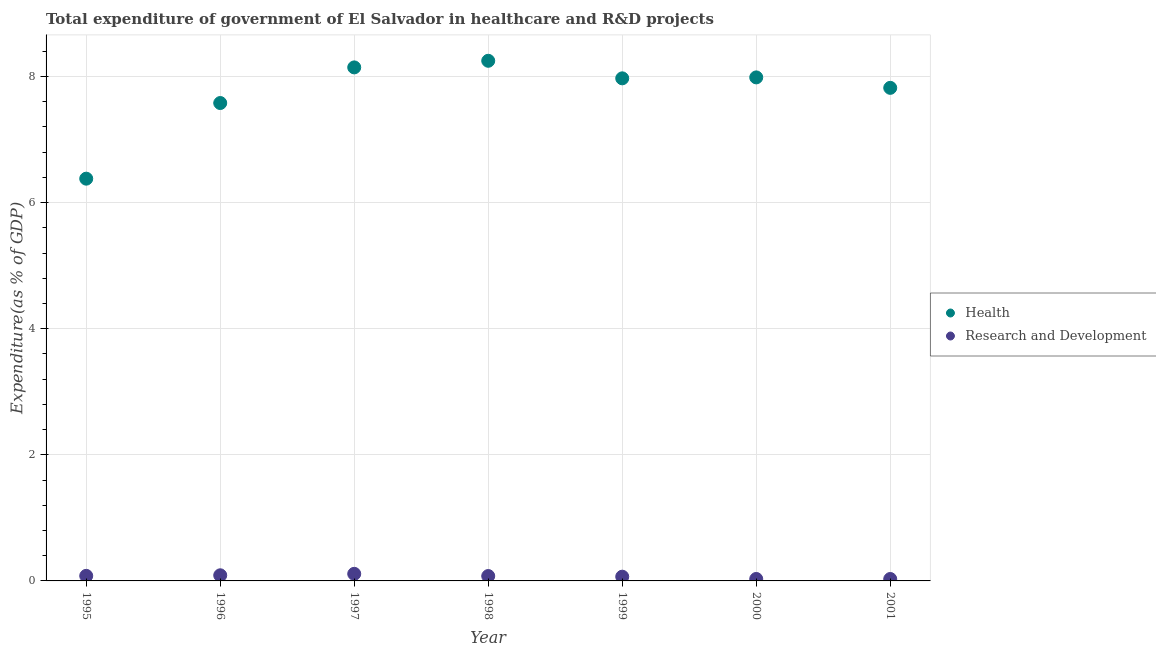Is the number of dotlines equal to the number of legend labels?
Give a very brief answer. Yes. What is the expenditure in r&d in 1997?
Your response must be concise. 0.11. Across all years, what is the maximum expenditure in healthcare?
Keep it short and to the point. 8.25. Across all years, what is the minimum expenditure in healthcare?
Provide a succinct answer. 6.38. In which year was the expenditure in healthcare maximum?
Keep it short and to the point. 1998. What is the total expenditure in healthcare in the graph?
Ensure brevity in your answer.  54.12. What is the difference between the expenditure in healthcare in 1997 and that in 1999?
Provide a short and direct response. 0.17. What is the difference between the expenditure in healthcare in 2001 and the expenditure in r&d in 1995?
Your answer should be very brief. 7.74. What is the average expenditure in healthcare per year?
Make the answer very short. 7.73. In the year 1997, what is the difference between the expenditure in r&d and expenditure in healthcare?
Your answer should be compact. -8.03. What is the ratio of the expenditure in r&d in 1996 to that in 1999?
Ensure brevity in your answer.  1.33. Is the expenditure in r&d in 1996 less than that in 1998?
Offer a very short reply. No. What is the difference between the highest and the second highest expenditure in healthcare?
Give a very brief answer. 0.1. What is the difference between the highest and the lowest expenditure in r&d?
Provide a short and direct response. 0.08. Is the sum of the expenditure in healthcare in 1995 and 2001 greater than the maximum expenditure in r&d across all years?
Your answer should be compact. Yes. Is the expenditure in r&d strictly greater than the expenditure in healthcare over the years?
Give a very brief answer. No. Is the expenditure in healthcare strictly less than the expenditure in r&d over the years?
Give a very brief answer. No. How many dotlines are there?
Offer a very short reply. 2. What is the difference between two consecutive major ticks on the Y-axis?
Give a very brief answer. 2. Are the values on the major ticks of Y-axis written in scientific E-notation?
Ensure brevity in your answer.  No. Does the graph contain grids?
Keep it short and to the point. Yes. Where does the legend appear in the graph?
Provide a succinct answer. Center right. What is the title of the graph?
Your response must be concise. Total expenditure of government of El Salvador in healthcare and R&D projects. What is the label or title of the Y-axis?
Provide a short and direct response. Expenditure(as % of GDP). What is the Expenditure(as % of GDP) of Health in 1995?
Offer a very short reply. 6.38. What is the Expenditure(as % of GDP) of Research and Development in 1995?
Offer a terse response. 0.08. What is the Expenditure(as % of GDP) of Health in 1996?
Offer a very short reply. 7.58. What is the Expenditure(as % of GDP) in Research and Development in 1996?
Offer a very short reply. 0.09. What is the Expenditure(as % of GDP) in Health in 1997?
Keep it short and to the point. 8.14. What is the Expenditure(as % of GDP) in Research and Development in 1997?
Your answer should be very brief. 0.11. What is the Expenditure(as % of GDP) of Health in 1998?
Keep it short and to the point. 8.25. What is the Expenditure(as % of GDP) of Research and Development in 1998?
Provide a short and direct response. 0.08. What is the Expenditure(as % of GDP) of Health in 1999?
Your answer should be very brief. 7.97. What is the Expenditure(as % of GDP) of Research and Development in 1999?
Ensure brevity in your answer.  0.07. What is the Expenditure(as % of GDP) in Health in 2000?
Offer a terse response. 7.98. What is the Expenditure(as % of GDP) in Research and Development in 2000?
Make the answer very short. 0.03. What is the Expenditure(as % of GDP) in Health in 2001?
Your response must be concise. 7.82. What is the Expenditure(as % of GDP) in Research and Development in 2001?
Keep it short and to the point. 0.03. Across all years, what is the maximum Expenditure(as % of GDP) of Health?
Give a very brief answer. 8.25. Across all years, what is the maximum Expenditure(as % of GDP) of Research and Development?
Offer a very short reply. 0.11. Across all years, what is the minimum Expenditure(as % of GDP) of Health?
Provide a succinct answer. 6.38. Across all years, what is the minimum Expenditure(as % of GDP) of Research and Development?
Make the answer very short. 0.03. What is the total Expenditure(as % of GDP) in Health in the graph?
Keep it short and to the point. 54.12. What is the total Expenditure(as % of GDP) in Research and Development in the graph?
Provide a succinct answer. 0.49. What is the difference between the Expenditure(as % of GDP) of Health in 1995 and that in 1996?
Offer a terse response. -1.2. What is the difference between the Expenditure(as % of GDP) in Research and Development in 1995 and that in 1996?
Ensure brevity in your answer.  -0.01. What is the difference between the Expenditure(as % of GDP) of Health in 1995 and that in 1997?
Offer a very short reply. -1.76. What is the difference between the Expenditure(as % of GDP) of Research and Development in 1995 and that in 1997?
Your answer should be very brief. -0.03. What is the difference between the Expenditure(as % of GDP) of Health in 1995 and that in 1998?
Ensure brevity in your answer.  -1.87. What is the difference between the Expenditure(as % of GDP) of Research and Development in 1995 and that in 1998?
Make the answer very short. 0. What is the difference between the Expenditure(as % of GDP) of Health in 1995 and that in 1999?
Provide a short and direct response. -1.59. What is the difference between the Expenditure(as % of GDP) of Research and Development in 1995 and that in 1999?
Your answer should be compact. 0.01. What is the difference between the Expenditure(as % of GDP) of Health in 1995 and that in 2000?
Ensure brevity in your answer.  -1.61. What is the difference between the Expenditure(as % of GDP) of Research and Development in 1995 and that in 2000?
Make the answer very short. 0.05. What is the difference between the Expenditure(as % of GDP) in Health in 1995 and that in 2001?
Make the answer very short. -1.44. What is the difference between the Expenditure(as % of GDP) of Research and Development in 1995 and that in 2001?
Offer a very short reply. 0.05. What is the difference between the Expenditure(as % of GDP) in Health in 1996 and that in 1997?
Make the answer very short. -0.56. What is the difference between the Expenditure(as % of GDP) of Research and Development in 1996 and that in 1997?
Ensure brevity in your answer.  -0.02. What is the difference between the Expenditure(as % of GDP) of Health in 1996 and that in 1998?
Offer a very short reply. -0.67. What is the difference between the Expenditure(as % of GDP) in Research and Development in 1996 and that in 1998?
Provide a short and direct response. 0.01. What is the difference between the Expenditure(as % of GDP) in Health in 1996 and that in 1999?
Ensure brevity in your answer.  -0.39. What is the difference between the Expenditure(as % of GDP) in Research and Development in 1996 and that in 1999?
Offer a very short reply. 0.02. What is the difference between the Expenditure(as % of GDP) in Health in 1996 and that in 2000?
Ensure brevity in your answer.  -0.41. What is the difference between the Expenditure(as % of GDP) of Research and Development in 1996 and that in 2000?
Offer a terse response. 0.06. What is the difference between the Expenditure(as % of GDP) in Health in 1996 and that in 2001?
Keep it short and to the point. -0.24. What is the difference between the Expenditure(as % of GDP) in Research and Development in 1996 and that in 2001?
Ensure brevity in your answer.  0.06. What is the difference between the Expenditure(as % of GDP) in Health in 1997 and that in 1998?
Offer a very short reply. -0.1. What is the difference between the Expenditure(as % of GDP) of Research and Development in 1997 and that in 1998?
Keep it short and to the point. 0.04. What is the difference between the Expenditure(as % of GDP) in Health in 1997 and that in 1999?
Your response must be concise. 0.17. What is the difference between the Expenditure(as % of GDP) of Research and Development in 1997 and that in 1999?
Your answer should be compact. 0.05. What is the difference between the Expenditure(as % of GDP) in Health in 1997 and that in 2000?
Give a very brief answer. 0.16. What is the difference between the Expenditure(as % of GDP) of Research and Development in 1997 and that in 2000?
Your answer should be very brief. 0.08. What is the difference between the Expenditure(as % of GDP) of Health in 1997 and that in 2001?
Offer a terse response. 0.32. What is the difference between the Expenditure(as % of GDP) in Research and Development in 1997 and that in 2001?
Your response must be concise. 0.08. What is the difference between the Expenditure(as % of GDP) in Health in 1998 and that in 1999?
Provide a succinct answer. 0.28. What is the difference between the Expenditure(as % of GDP) in Research and Development in 1998 and that in 1999?
Your answer should be compact. 0.01. What is the difference between the Expenditure(as % of GDP) in Health in 1998 and that in 2000?
Your response must be concise. 0.26. What is the difference between the Expenditure(as % of GDP) in Research and Development in 1998 and that in 2000?
Offer a terse response. 0.05. What is the difference between the Expenditure(as % of GDP) of Health in 1998 and that in 2001?
Offer a very short reply. 0.43. What is the difference between the Expenditure(as % of GDP) in Research and Development in 1998 and that in 2001?
Provide a succinct answer. 0.05. What is the difference between the Expenditure(as % of GDP) of Health in 1999 and that in 2000?
Give a very brief answer. -0.01. What is the difference between the Expenditure(as % of GDP) in Research and Development in 1999 and that in 2000?
Provide a succinct answer. 0.04. What is the difference between the Expenditure(as % of GDP) of Health in 1999 and that in 2001?
Your answer should be compact. 0.15. What is the difference between the Expenditure(as % of GDP) in Research and Development in 1999 and that in 2001?
Ensure brevity in your answer.  0.04. What is the difference between the Expenditure(as % of GDP) of Health in 2000 and that in 2001?
Your response must be concise. 0.17. What is the difference between the Expenditure(as % of GDP) of Research and Development in 2000 and that in 2001?
Make the answer very short. 0. What is the difference between the Expenditure(as % of GDP) of Health in 1995 and the Expenditure(as % of GDP) of Research and Development in 1996?
Your response must be concise. 6.29. What is the difference between the Expenditure(as % of GDP) in Health in 1995 and the Expenditure(as % of GDP) in Research and Development in 1997?
Your answer should be compact. 6.27. What is the difference between the Expenditure(as % of GDP) of Health in 1995 and the Expenditure(as % of GDP) of Research and Development in 1998?
Your answer should be very brief. 6.3. What is the difference between the Expenditure(as % of GDP) of Health in 1995 and the Expenditure(as % of GDP) of Research and Development in 1999?
Ensure brevity in your answer.  6.31. What is the difference between the Expenditure(as % of GDP) in Health in 1995 and the Expenditure(as % of GDP) in Research and Development in 2000?
Make the answer very short. 6.35. What is the difference between the Expenditure(as % of GDP) in Health in 1995 and the Expenditure(as % of GDP) in Research and Development in 2001?
Provide a succinct answer. 6.35. What is the difference between the Expenditure(as % of GDP) in Health in 1996 and the Expenditure(as % of GDP) in Research and Development in 1997?
Ensure brevity in your answer.  7.47. What is the difference between the Expenditure(as % of GDP) of Health in 1996 and the Expenditure(as % of GDP) of Research and Development in 1998?
Your answer should be very brief. 7.5. What is the difference between the Expenditure(as % of GDP) of Health in 1996 and the Expenditure(as % of GDP) of Research and Development in 1999?
Make the answer very short. 7.51. What is the difference between the Expenditure(as % of GDP) of Health in 1996 and the Expenditure(as % of GDP) of Research and Development in 2000?
Your answer should be compact. 7.55. What is the difference between the Expenditure(as % of GDP) in Health in 1996 and the Expenditure(as % of GDP) in Research and Development in 2001?
Your answer should be very brief. 7.55. What is the difference between the Expenditure(as % of GDP) in Health in 1997 and the Expenditure(as % of GDP) in Research and Development in 1998?
Your response must be concise. 8.07. What is the difference between the Expenditure(as % of GDP) of Health in 1997 and the Expenditure(as % of GDP) of Research and Development in 1999?
Give a very brief answer. 8.08. What is the difference between the Expenditure(as % of GDP) in Health in 1997 and the Expenditure(as % of GDP) in Research and Development in 2000?
Provide a short and direct response. 8.11. What is the difference between the Expenditure(as % of GDP) of Health in 1997 and the Expenditure(as % of GDP) of Research and Development in 2001?
Offer a terse response. 8.11. What is the difference between the Expenditure(as % of GDP) of Health in 1998 and the Expenditure(as % of GDP) of Research and Development in 1999?
Offer a very short reply. 8.18. What is the difference between the Expenditure(as % of GDP) of Health in 1998 and the Expenditure(as % of GDP) of Research and Development in 2000?
Your response must be concise. 8.22. What is the difference between the Expenditure(as % of GDP) in Health in 1998 and the Expenditure(as % of GDP) in Research and Development in 2001?
Offer a very short reply. 8.22. What is the difference between the Expenditure(as % of GDP) of Health in 1999 and the Expenditure(as % of GDP) of Research and Development in 2000?
Offer a very short reply. 7.94. What is the difference between the Expenditure(as % of GDP) in Health in 1999 and the Expenditure(as % of GDP) in Research and Development in 2001?
Keep it short and to the point. 7.94. What is the difference between the Expenditure(as % of GDP) of Health in 2000 and the Expenditure(as % of GDP) of Research and Development in 2001?
Your answer should be very brief. 7.95. What is the average Expenditure(as % of GDP) of Health per year?
Your response must be concise. 7.73. What is the average Expenditure(as % of GDP) in Research and Development per year?
Make the answer very short. 0.07. In the year 1995, what is the difference between the Expenditure(as % of GDP) of Health and Expenditure(as % of GDP) of Research and Development?
Your answer should be compact. 6.3. In the year 1996, what is the difference between the Expenditure(as % of GDP) in Health and Expenditure(as % of GDP) in Research and Development?
Make the answer very short. 7.49. In the year 1997, what is the difference between the Expenditure(as % of GDP) of Health and Expenditure(as % of GDP) of Research and Development?
Your answer should be compact. 8.03. In the year 1998, what is the difference between the Expenditure(as % of GDP) of Health and Expenditure(as % of GDP) of Research and Development?
Your answer should be compact. 8.17. In the year 1999, what is the difference between the Expenditure(as % of GDP) in Health and Expenditure(as % of GDP) in Research and Development?
Keep it short and to the point. 7.9. In the year 2000, what is the difference between the Expenditure(as % of GDP) of Health and Expenditure(as % of GDP) of Research and Development?
Your answer should be very brief. 7.95. In the year 2001, what is the difference between the Expenditure(as % of GDP) of Health and Expenditure(as % of GDP) of Research and Development?
Give a very brief answer. 7.79. What is the ratio of the Expenditure(as % of GDP) of Health in 1995 to that in 1996?
Your response must be concise. 0.84. What is the ratio of the Expenditure(as % of GDP) in Research and Development in 1995 to that in 1996?
Offer a very short reply. 0.9. What is the ratio of the Expenditure(as % of GDP) of Health in 1995 to that in 1997?
Offer a terse response. 0.78. What is the ratio of the Expenditure(as % of GDP) of Research and Development in 1995 to that in 1997?
Keep it short and to the point. 0.71. What is the ratio of the Expenditure(as % of GDP) of Health in 1995 to that in 1998?
Provide a succinct answer. 0.77. What is the ratio of the Expenditure(as % of GDP) of Research and Development in 1995 to that in 1998?
Your answer should be compact. 1.04. What is the ratio of the Expenditure(as % of GDP) in Health in 1995 to that in 1999?
Ensure brevity in your answer.  0.8. What is the ratio of the Expenditure(as % of GDP) in Research and Development in 1995 to that in 1999?
Give a very brief answer. 1.19. What is the ratio of the Expenditure(as % of GDP) of Health in 1995 to that in 2000?
Your response must be concise. 0.8. What is the ratio of the Expenditure(as % of GDP) in Research and Development in 1995 to that in 2000?
Ensure brevity in your answer.  2.58. What is the ratio of the Expenditure(as % of GDP) of Health in 1995 to that in 2001?
Your answer should be very brief. 0.82. What is the ratio of the Expenditure(as % of GDP) in Research and Development in 1995 to that in 2001?
Provide a short and direct response. 2.63. What is the ratio of the Expenditure(as % of GDP) in Health in 1996 to that in 1997?
Provide a short and direct response. 0.93. What is the ratio of the Expenditure(as % of GDP) in Research and Development in 1996 to that in 1997?
Your response must be concise. 0.79. What is the ratio of the Expenditure(as % of GDP) in Health in 1996 to that in 1998?
Your answer should be very brief. 0.92. What is the ratio of the Expenditure(as % of GDP) of Research and Development in 1996 to that in 1998?
Your response must be concise. 1.15. What is the ratio of the Expenditure(as % of GDP) of Health in 1996 to that in 1999?
Keep it short and to the point. 0.95. What is the ratio of the Expenditure(as % of GDP) in Research and Development in 1996 to that in 1999?
Keep it short and to the point. 1.33. What is the ratio of the Expenditure(as % of GDP) in Health in 1996 to that in 2000?
Give a very brief answer. 0.95. What is the ratio of the Expenditure(as % of GDP) of Research and Development in 1996 to that in 2000?
Your answer should be very brief. 2.87. What is the ratio of the Expenditure(as % of GDP) in Health in 1996 to that in 2001?
Give a very brief answer. 0.97. What is the ratio of the Expenditure(as % of GDP) of Research and Development in 1996 to that in 2001?
Provide a short and direct response. 2.93. What is the ratio of the Expenditure(as % of GDP) in Health in 1997 to that in 1998?
Provide a succinct answer. 0.99. What is the ratio of the Expenditure(as % of GDP) of Research and Development in 1997 to that in 1998?
Offer a terse response. 1.45. What is the ratio of the Expenditure(as % of GDP) of Health in 1997 to that in 1999?
Your response must be concise. 1.02. What is the ratio of the Expenditure(as % of GDP) of Research and Development in 1997 to that in 1999?
Provide a succinct answer. 1.67. What is the ratio of the Expenditure(as % of GDP) in Health in 1997 to that in 2000?
Give a very brief answer. 1.02. What is the ratio of the Expenditure(as % of GDP) in Research and Development in 1997 to that in 2000?
Your answer should be compact. 3.61. What is the ratio of the Expenditure(as % of GDP) of Health in 1997 to that in 2001?
Offer a very short reply. 1.04. What is the ratio of the Expenditure(as % of GDP) of Research and Development in 1997 to that in 2001?
Provide a succinct answer. 3.69. What is the ratio of the Expenditure(as % of GDP) in Health in 1998 to that in 1999?
Offer a very short reply. 1.03. What is the ratio of the Expenditure(as % of GDP) in Research and Development in 1998 to that in 1999?
Offer a terse response. 1.15. What is the ratio of the Expenditure(as % of GDP) in Health in 1998 to that in 2000?
Make the answer very short. 1.03. What is the ratio of the Expenditure(as % of GDP) of Research and Development in 1998 to that in 2000?
Offer a terse response. 2.49. What is the ratio of the Expenditure(as % of GDP) of Health in 1998 to that in 2001?
Your answer should be compact. 1.05. What is the ratio of the Expenditure(as % of GDP) in Research and Development in 1998 to that in 2001?
Your answer should be very brief. 2.54. What is the ratio of the Expenditure(as % of GDP) of Research and Development in 1999 to that in 2000?
Keep it short and to the point. 2.16. What is the ratio of the Expenditure(as % of GDP) of Health in 1999 to that in 2001?
Offer a terse response. 1.02. What is the ratio of the Expenditure(as % of GDP) of Research and Development in 1999 to that in 2001?
Give a very brief answer. 2.2. What is the ratio of the Expenditure(as % of GDP) of Health in 2000 to that in 2001?
Ensure brevity in your answer.  1.02. What is the difference between the highest and the second highest Expenditure(as % of GDP) of Health?
Offer a terse response. 0.1. What is the difference between the highest and the second highest Expenditure(as % of GDP) of Research and Development?
Keep it short and to the point. 0.02. What is the difference between the highest and the lowest Expenditure(as % of GDP) in Health?
Give a very brief answer. 1.87. What is the difference between the highest and the lowest Expenditure(as % of GDP) of Research and Development?
Your answer should be very brief. 0.08. 